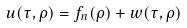Convert formula to latex. <formula><loc_0><loc_0><loc_500><loc_500>u ( \tau , \rho ) = f _ { n } ( \rho ) + w ( \tau , \rho )</formula> 